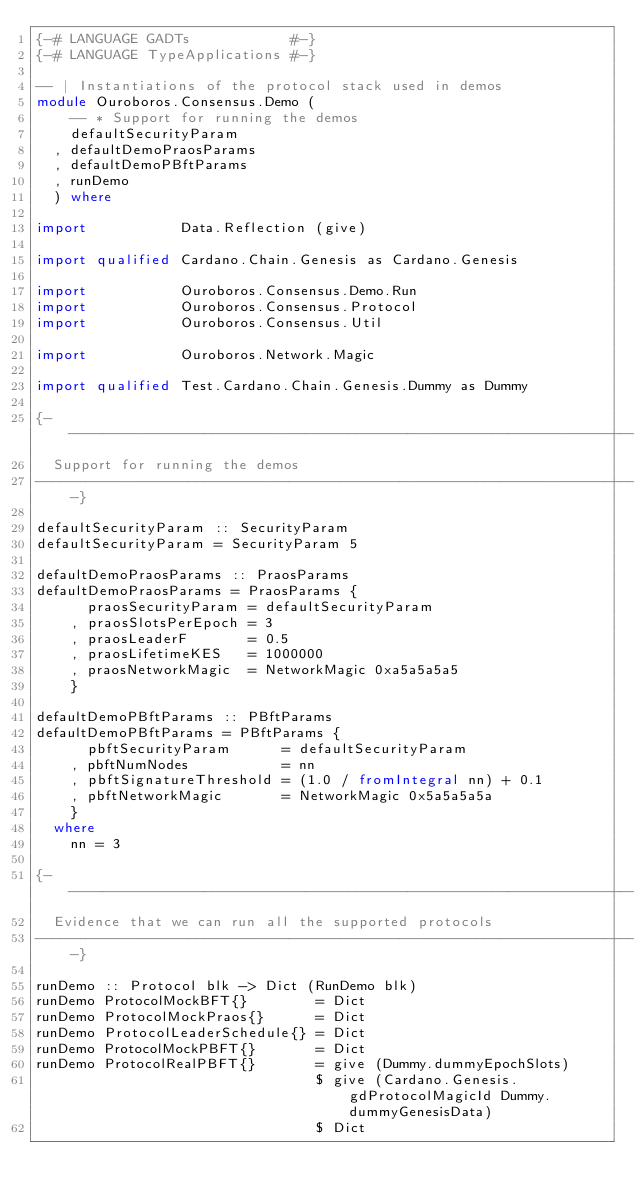<code> <loc_0><loc_0><loc_500><loc_500><_Haskell_>{-# LANGUAGE GADTs            #-}
{-# LANGUAGE TypeApplications #-}

-- | Instantiations of the protocol stack used in demos
module Ouroboros.Consensus.Demo (
    -- * Support for running the demos
    defaultSecurityParam
  , defaultDemoPraosParams
  , defaultDemoPBftParams
  , runDemo
  ) where

import           Data.Reflection (give)

import qualified Cardano.Chain.Genesis as Cardano.Genesis

import           Ouroboros.Consensus.Demo.Run
import           Ouroboros.Consensus.Protocol
import           Ouroboros.Consensus.Util

import           Ouroboros.Network.Magic

import qualified Test.Cardano.Chain.Genesis.Dummy as Dummy

{-------------------------------------------------------------------------------
  Support for running the demos
-------------------------------------------------------------------------------}

defaultSecurityParam :: SecurityParam
defaultSecurityParam = SecurityParam 5

defaultDemoPraosParams :: PraosParams
defaultDemoPraosParams = PraosParams {
      praosSecurityParam = defaultSecurityParam
    , praosSlotsPerEpoch = 3
    , praosLeaderF       = 0.5
    , praosLifetimeKES   = 1000000
    , praosNetworkMagic  = NetworkMagic 0xa5a5a5a5
    }

defaultDemoPBftParams :: PBftParams
defaultDemoPBftParams = PBftParams {
      pbftSecurityParam      = defaultSecurityParam
    , pbftNumNodes           = nn
    , pbftSignatureThreshold = (1.0 / fromIntegral nn) + 0.1
    , pbftNetworkMagic       = NetworkMagic 0x5a5a5a5a
    }
  where
    nn = 3

{-------------------------------------------------------------------------------
  Evidence that we can run all the supported protocols
-------------------------------------------------------------------------------}

runDemo :: Protocol blk -> Dict (RunDemo blk)
runDemo ProtocolMockBFT{}        = Dict
runDemo ProtocolMockPraos{}      = Dict
runDemo ProtocolLeaderSchedule{} = Dict
runDemo ProtocolMockPBFT{}       = Dict
runDemo ProtocolRealPBFT{}       = give (Dummy.dummyEpochSlots)
                                 $ give (Cardano.Genesis.gdProtocolMagicId Dummy.dummyGenesisData)
                                 $ Dict
</code> 